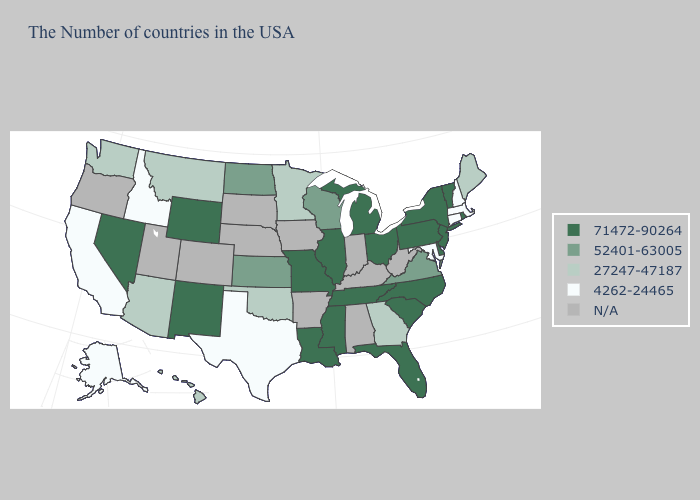Is the legend a continuous bar?
Keep it brief. No. What is the value of Iowa?
Concise answer only. N/A. Which states have the lowest value in the USA?
Quick response, please. Massachusetts, New Hampshire, Connecticut, Maryland, Texas, Idaho, California, Alaska. Name the states that have a value in the range N/A?
Write a very short answer. West Virginia, Kentucky, Indiana, Alabama, Arkansas, Iowa, Nebraska, South Dakota, Colorado, Utah, Oregon. Name the states that have a value in the range 27247-47187?
Write a very short answer. Maine, Georgia, Minnesota, Oklahoma, Montana, Arizona, Washington, Hawaii. Name the states that have a value in the range 71472-90264?
Give a very brief answer. Rhode Island, Vermont, New York, New Jersey, Delaware, Pennsylvania, North Carolina, South Carolina, Ohio, Florida, Michigan, Tennessee, Illinois, Mississippi, Louisiana, Missouri, Wyoming, New Mexico, Nevada. Name the states that have a value in the range 71472-90264?
Give a very brief answer. Rhode Island, Vermont, New York, New Jersey, Delaware, Pennsylvania, North Carolina, South Carolina, Ohio, Florida, Michigan, Tennessee, Illinois, Mississippi, Louisiana, Missouri, Wyoming, New Mexico, Nevada. Name the states that have a value in the range 71472-90264?
Concise answer only. Rhode Island, Vermont, New York, New Jersey, Delaware, Pennsylvania, North Carolina, South Carolina, Ohio, Florida, Michigan, Tennessee, Illinois, Mississippi, Louisiana, Missouri, Wyoming, New Mexico, Nevada. Name the states that have a value in the range 27247-47187?
Be succinct. Maine, Georgia, Minnesota, Oklahoma, Montana, Arizona, Washington, Hawaii. Does New York have the highest value in the USA?
Short answer required. Yes. What is the value of Maryland?
Quick response, please. 4262-24465. What is the highest value in the West ?
Give a very brief answer. 71472-90264. What is the highest value in the West ?
Write a very short answer. 71472-90264. Among the states that border Arkansas , does Mississippi have the lowest value?
Short answer required. No. Name the states that have a value in the range N/A?
Be succinct. West Virginia, Kentucky, Indiana, Alabama, Arkansas, Iowa, Nebraska, South Dakota, Colorado, Utah, Oregon. 